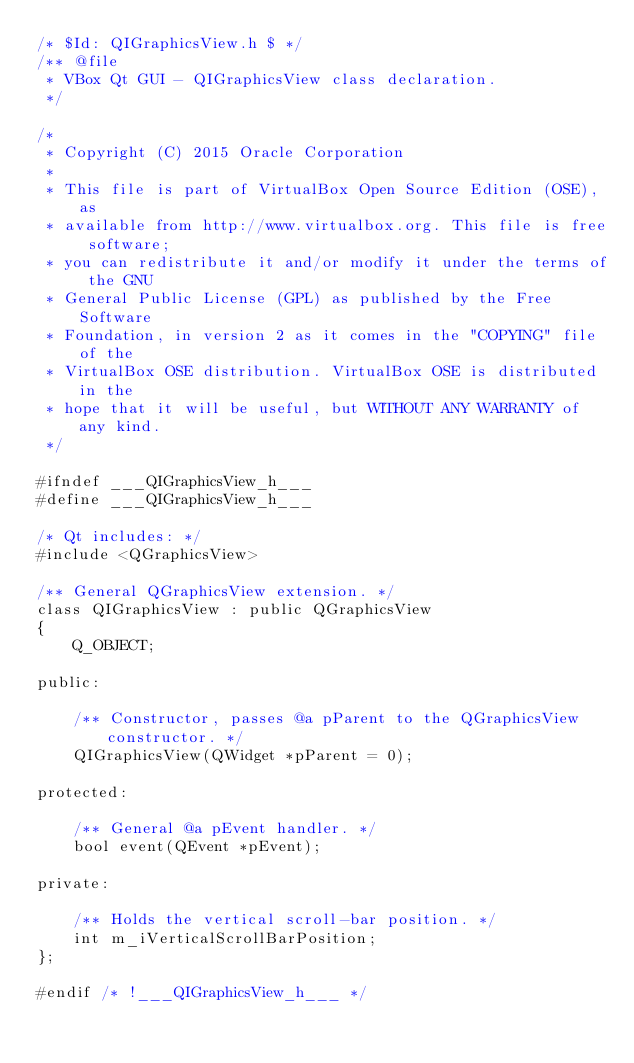<code> <loc_0><loc_0><loc_500><loc_500><_C_>/* $Id: QIGraphicsView.h $ */
/** @file
 * VBox Qt GUI - QIGraphicsView class declaration.
 */

/*
 * Copyright (C) 2015 Oracle Corporation
 *
 * This file is part of VirtualBox Open Source Edition (OSE), as
 * available from http://www.virtualbox.org. This file is free software;
 * you can redistribute it and/or modify it under the terms of the GNU
 * General Public License (GPL) as published by the Free Software
 * Foundation, in version 2 as it comes in the "COPYING" file of the
 * VirtualBox OSE distribution. VirtualBox OSE is distributed in the
 * hope that it will be useful, but WITHOUT ANY WARRANTY of any kind.
 */

#ifndef ___QIGraphicsView_h___
#define ___QIGraphicsView_h___

/* Qt includes: */
#include <QGraphicsView>

/** General QGraphicsView extension. */
class QIGraphicsView : public QGraphicsView
{
    Q_OBJECT;

public:

    /** Constructor, passes @a pParent to the QGraphicsView constructor. */
    QIGraphicsView(QWidget *pParent = 0);

protected:

    /** General @a pEvent handler. */
    bool event(QEvent *pEvent);

private:

    /** Holds the vertical scroll-bar position. */
    int m_iVerticalScrollBarPosition;
};

#endif /* !___QIGraphicsView_h___ */

</code> 